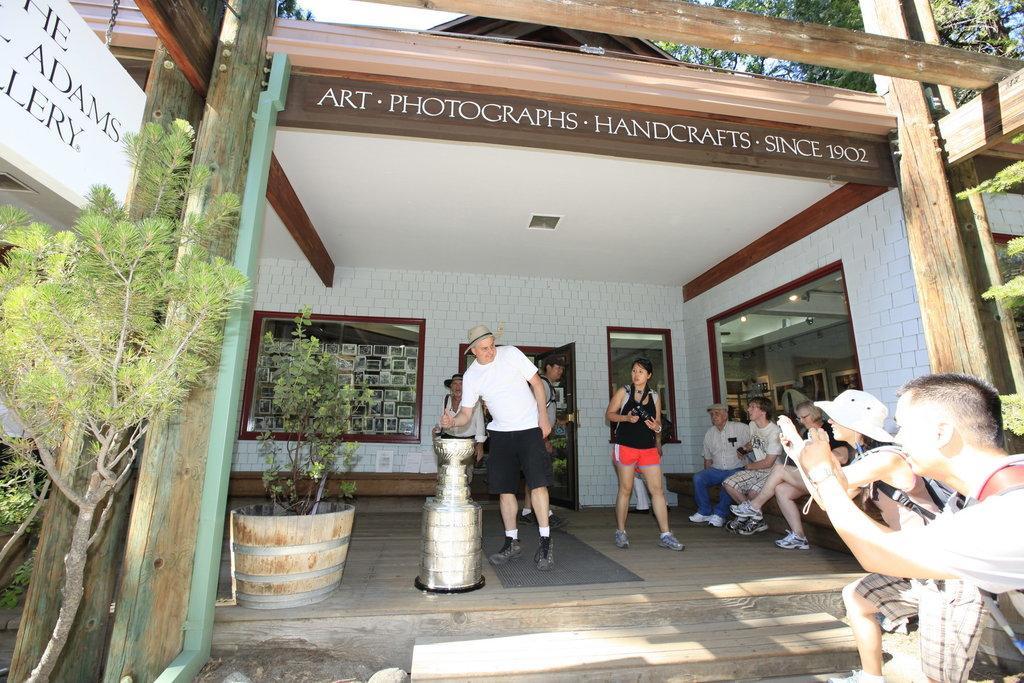How would you summarize this image in a sentence or two? Here in this picture on the right side we can see some people sitting over a place and we can see some people standing and the person on the extreme right side is clicking photographs of the person who is standing in the middle and we can see some plants and tree present and we can also see a hoarding and on the wall we can see some photographs present. 